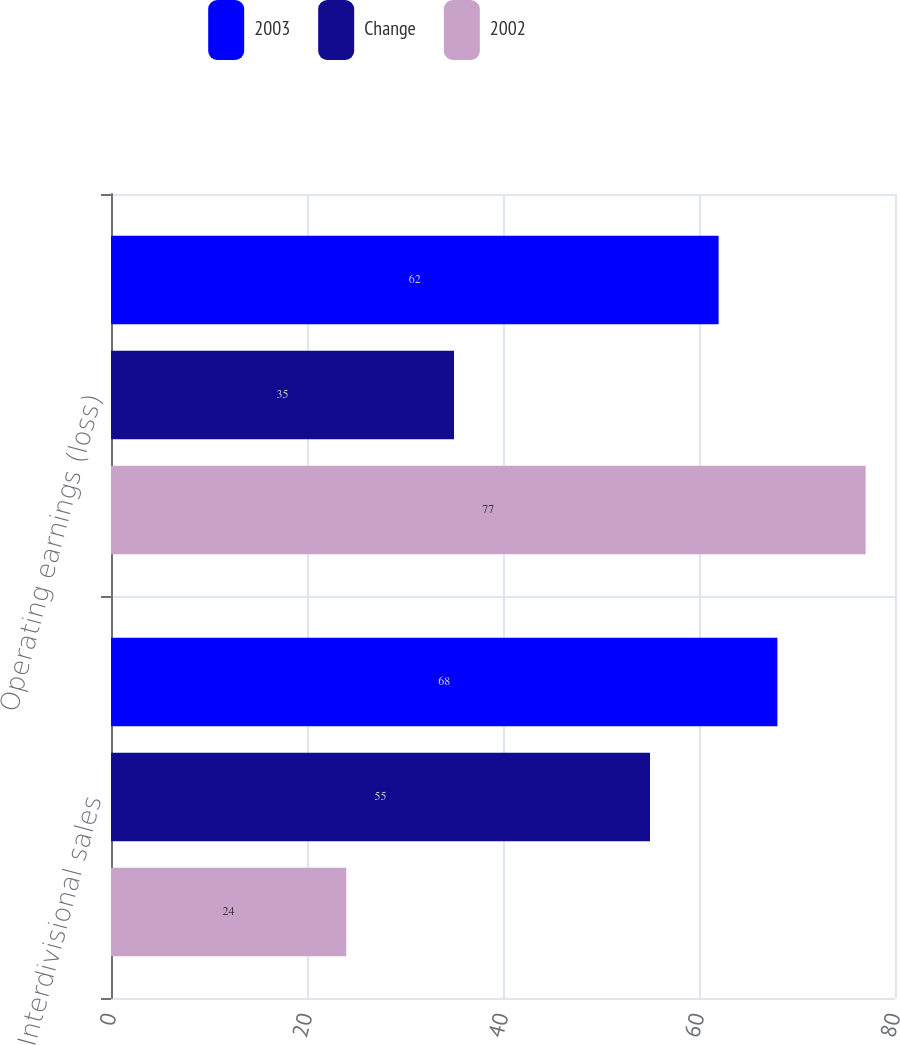Convert chart to OTSL. <chart><loc_0><loc_0><loc_500><loc_500><stacked_bar_chart><ecel><fcel>Interdivisional sales<fcel>Operating earnings (loss)<nl><fcel>2003<fcel>68<fcel>62<nl><fcel>Change<fcel>55<fcel>35<nl><fcel>2002<fcel>24<fcel>77<nl></chart> 